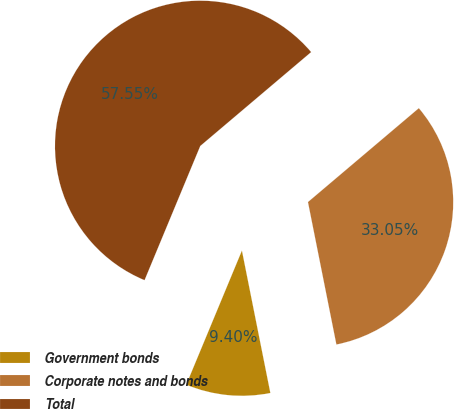<chart> <loc_0><loc_0><loc_500><loc_500><pie_chart><fcel>Government bonds<fcel>Corporate notes and bonds<fcel>Total<nl><fcel>9.4%<fcel>33.05%<fcel>57.56%<nl></chart> 